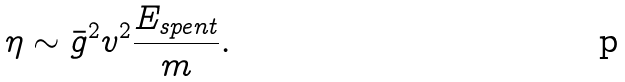Convert formula to latex. <formula><loc_0><loc_0><loc_500><loc_500>\eta \sim \bar { g } ^ { 2 } v ^ { 2 } \frac { E _ { s p e n t } } { m } .</formula> 